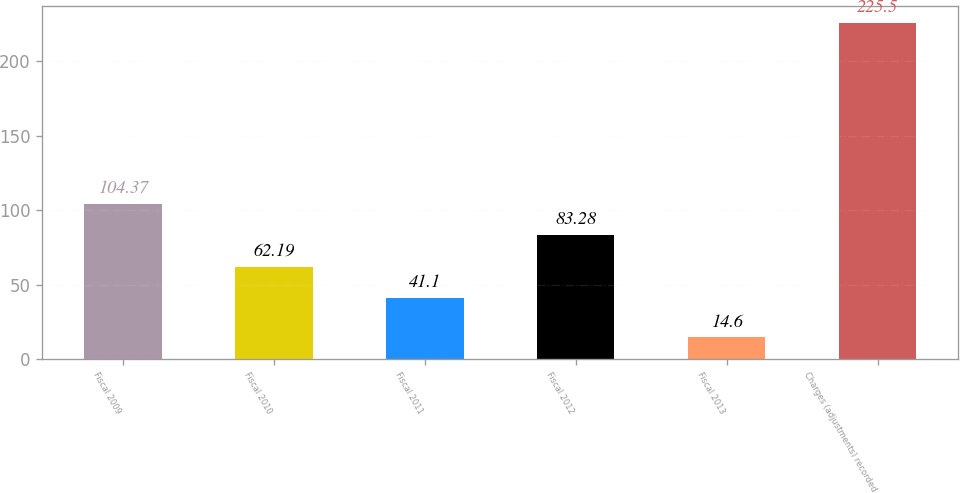Convert chart to OTSL. <chart><loc_0><loc_0><loc_500><loc_500><bar_chart><fcel>Fiscal 2009<fcel>Fiscal 2010<fcel>Fiscal 2011<fcel>Fiscal 2012<fcel>Fiscal 2013<fcel>Charges (adjustments) recorded<nl><fcel>104.37<fcel>62.19<fcel>41.1<fcel>83.28<fcel>14.6<fcel>225.5<nl></chart> 